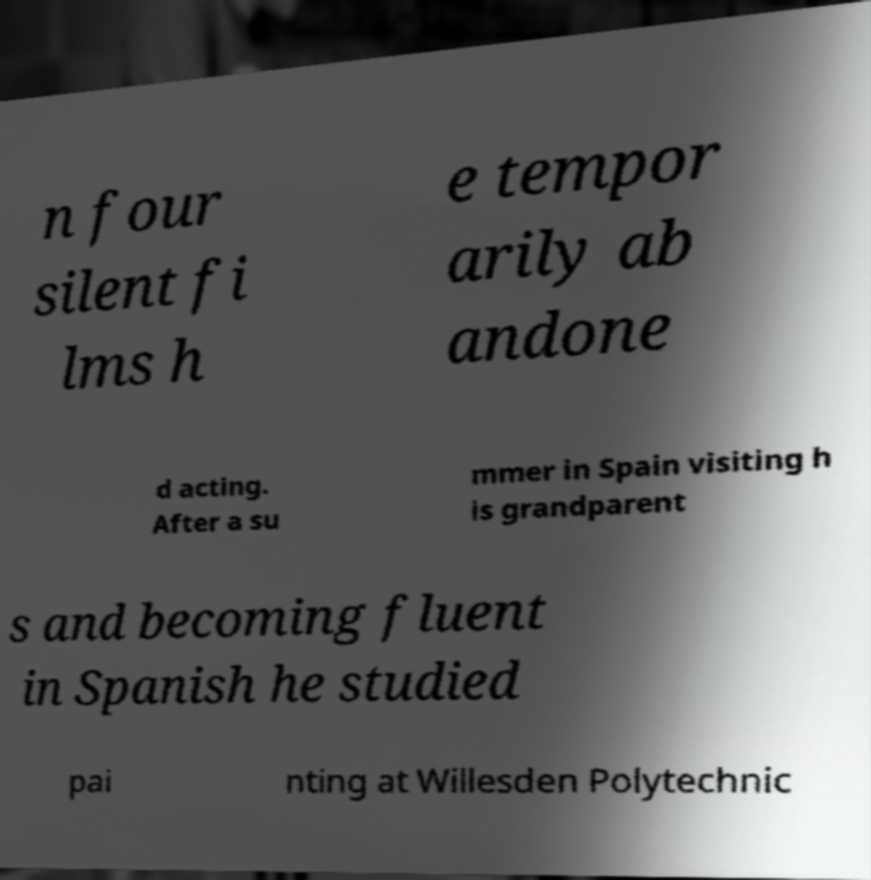There's text embedded in this image that I need extracted. Can you transcribe it verbatim? n four silent fi lms h e tempor arily ab andone d acting. After a su mmer in Spain visiting h is grandparent s and becoming fluent in Spanish he studied pai nting at Willesden Polytechnic 